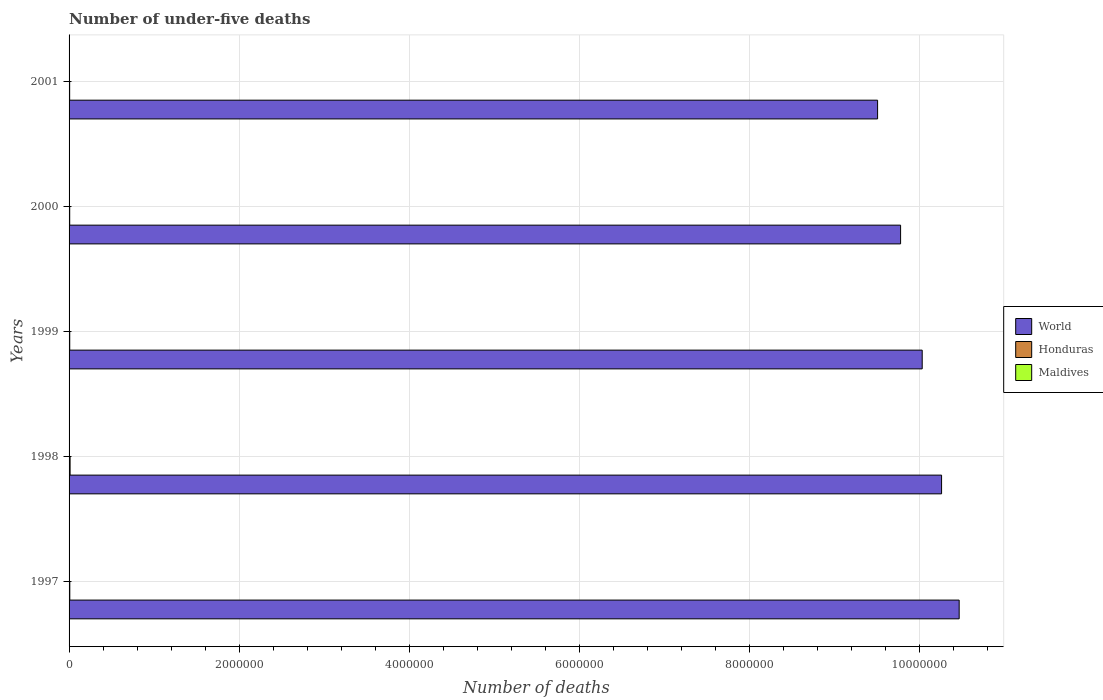Are the number of bars per tick equal to the number of legend labels?
Ensure brevity in your answer.  Yes. How many bars are there on the 5th tick from the bottom?
Offer a terse response. 3. What is the label of the 1st group of bars from the top?
Your answer should be compact. 2001. In how many cases, is the number of bars for a given year not equal to the number of legend labels?
Keep it short and to the point. 0. What is the number of under-five deaths in Honduras in 1999?
Offer a terse response. 7737. Across all years, what is the maximum number of under-five deaths in Honduras?
Offer a terse response. 1.20e+04. Across all years, what is the minimum number of under-five deaths in Honduras?
Your answer should be very brief. 6961. In which year was the number of under-five deaths in Honduras maximum?
Your answer should be compact. 1998. In which year was the number of under-five deaths in Honduras minimum?
Your answer should be very brief. 2001. What is the total number of under-five deaths in World in the graph?
Provide a succinct answer. 5.01e+07. What is the difference between the number of under-five deaths in World in 1997 and that in 2001?
Offer a terse response. 9.60e+05. What is the difference between the number of under-five deaths in Honduras in 1997 and the number of under-five deaths in Maldives in 1999?
Your answer should be very brief. 8169. What is the average number of under-five deaths in Honduras per year?
Your answer should be very brief. 8505.4. In the year 1997, what is the difference between the number of under-five deaths in Maldives and number of under-five deaths in World?
Make the answer very short. -1.05e+07. In how many years, is the number of under-five deaths in World greater than 6800000 ?
Offer a terse response. 5. What is the ratio of the number of under-five deaths in World in 1999 to that in 2000?
Your response must be concise. 1.03. Is the number of under-five deaths in Maldives in 1998 less than that in 1999?
Your response must be concise. No. Is the difference between the number of under-five deaths in Maldives in 1997 and 2000 greater than the difference between the number of under-five deaths in World in 1997 and 2000?
Your answer should be compact. No. What is the difference between the highest and the second highest number of under-five deaths in Honduras?
Your response must be concise. 3490. What is the difference between the highest and the lowest number of under-five deaths in World?
Provide a succinct answer. 9.60e+05. Is the sum of the number of under-five deaths in Maldives in 1997 and 1999 greater than the maximum number of under-five deaths in World across all years?
Give a very brief answer. No. What does the 2nd bar from the top in 1999 represents?
Your answer should be very brief. Honduras. What does the 3rd bar from the bottom in 1998 represents?
Ensure brevity in your answer.  Maldives. Is it the case that in every year, the sum of the number of under-five deaths in Honduras and number of under-five deaths in World is greater than the number of under-five deaths in Maldives?
Your response must be concise. Yes. How are the legend labels stacked?
Offer a very short reply. Vertical. What is the title of the graph?
Offer a terse response. Number of under-five deaths. Does "Congo (Republic)" appear as one of the legend labels in the graph?
Keep it short and to the point. No. What is the label or title of the X-axis?
Your answer should be compact. Number of deaths. What is the label or title of the Y-axis?
Ensure brevity in your answer.  Years. What is the Number of deaths of World in 1997?
Ensure brevity in your answer.  1.05e+07. What is the Number of deaths of Honduras in 1997?
Your answer should be very brief. 8496. What is the Number of deaths of Maldives in 1997?
Your answer should be compact. 436. What is the Number of deaths of World in 1998?
Offer a very short reply. 1.03e+07. What is the Number of deaths in Honduras in 1998?
Keep it short and to the point. 1.20e+04. What is the Number of deaths of Maldives in 1998?
Provide a succinct answer. 379. What is the Number of deaths in World in 1999?
Ensure brevity in your answer.  1.00e+07. What is the Number of deaths in Honduras in 1999?
Provide a short and direct response. 7737. What is the Number of deaths in Maldives in 1999?
Your response must be concise. 327. What is the Number of deaths in World in 2000?
Your answer should be compact. 9.78e+06. What is the Number of deaths in Honduras in 2000?
Provide a succinct answer. 7347. What is the Number of deaths of Maldives in 2000?
Make the answer very short. 281. What is the Number of deaths of World in 2001?
Your answer should be very brief. 9.51e+06. What is the Number of deaths in Honduras in 2001?
Provide a short and direct response. 6961. What is the Number of deaths of Maldives in 2001?
Offer a very short reply. 242. Across all years, what is the maximum Number of deaths in World?
Offer a terse response. 1.05e+07. Across all years, what is the maximum Number of deaths in Honduras?
Keep it short and to the point. 1.20e+04. Across all years, what is the maximum Number of deaths of Maldives?
Ensure brevity in your answer.  436. Across all years, what is the minimum Number of deaths in World?
Make the answer very short. 9.51e+06. Across all years, what is the minimum Number of deaths of Honduras?
Ensure brevity in your answer.  6961. Across all years, what is the minimum Number of deaths of Maldives?
Ensure brevity in your answer.  242. What is the total Number of deaths in World in the graph?
Keep it short and to the point. 5.01e+07. What is the total Number of deaths of Honduras in the graph?
Your response must be concise. 4.25e+04. What is the total Number of deaths of Maldives in the graph?
Keep it short and to the point. 1665. What is the difference between the Number of deaths of World in 1997 and that in 1998?
Your answer should be compact. 2.07e+05. What is the difference between the Number of deaths of Honduras in 1997 and that in 1998?
Your response must be concise. -3490. What is the difference between the Number of deaths in Maldives in 1997 and that in 1998?
Offer a terse response. 57. What is the difference between the Number of deaths in World in 1997 and that in 1999?
Offer a terse response. 4.35e+05. What is the difference between the Number of deaths of Honduras in 1997 and that in 1999?
Keep it short and to the point. 759. What is the difference between the Number of deaths in Maldives in 1997 and that in 1999?
Offer a terse response. 109. What is the difference between the Number of deaths in World in 1997 and that in 2000?
Offer a very short reply. 6.89e+05. What is the difference between the Number of deaths of Honduras in 1997 and that in 2000?
Your answer should be compact. 1149. What is the difference between the Number of deaths in Maldives in 1997 and that in 2000?
Your response must be concise. 155. What is the difference between the Number of deaths of World in 1997 and that in 2001?
Provide a short and direct response. 9.60e+05. What is the difference between the Number of deaths of Honduras in 1997 and that in 2001?
Provide a short and direct response. 1535. What is the difference between the Number of deaths in Maldives in 1997 and that in 2001?
Your response must be concise. 194. What is the difference between the Number of deaths in World in 1998 and that in 1999?
Keep it short and to the point. 2.28e+05. What is the difference between the Number of deaths in Honduras in 1998 and that in 1999?
Offer a very short reply. 4249. What is the difference between the Number of deaths in World in 1998 and that in 2000?
Keep it short and to the point. 4.82e+05. What is the difference between the Number of deaths in Honduras in 1998 and that in 2000?
Keep it short and to the point. 4639. What is the difference between the Number of deaths of Maldives in 1998 and that in 2000?
Offer a terse response. 98. What is the difference between the Number of deaths of World in 1998 and that in 2001?
Your answer should be compact. 7.53e+05. What is the difference between the Number of deaths of Honduras in 1998 and that in 2001?
Offer a very short reply. 5025. What is the difference between the Number of deaths of Maldives in 1998 and that in 2001?
Offer a terse response. 137. What is the difference between the Number of deaths of World in 1999 and that in 2000?
Provide a succinct answer. 2.54e+05. What is the difference between the Number of deaths of Honduras in 1999 and that in 2000?
Your response must be concise. 390. What is the difference between the Number of deaths in Maldives in 1999 and that in 2000?
Offer a terse response. 46. What is the difference between the Number of deaths of World in 1999 and that in 2001?
Provide a succinct answer. 5.25e+05. What is the difference between the Number of deaths in Honduras in 1999 and that in 2001?
Your answer should be very brief. 776. What is the difference between the Number of deaths in World in 2000 and that in 2001?
Your response must be concise. 2.71e+05. What is the difference between the Number of deaths in Honduras in 2000 and that in 2001?
Your response must be concise. 386. What is the difference between the Number of deaths of Maldives in 2000 and that in 2001?
Give a very brief answer. 39. What is the difference between the Number of deaths of World in 1997 and the Number of deaths of Honduras in 1998?
Give a very brief answer. 1.05e+07. What is the difference between the Number of deaths of World in 1997 and the Number of deaths of Maldives in 1998?
Offer a terse response. 1.05e+07. What is the difference between the Number of deaths of Honduras in 1997 and the Number of deaths of Maldives in 1998?
Ensure brevity in your answer.  8117. What is the difference between the Number of deaths of World in 1997 and the Number of deaths of Honduras in 1999?
Offer a terse response. 1.05e+07. What is the difference between the Number of deaths of World in 1997 and the Number of deaths of Maldives in 1999?
Your answer should be compact. 1.05e+07. What is the difference between the Number of deaths of Honduras in 1997 and the Number of deaths of Maldives in 1999?
Your response must be concise. 8169. What is the difference between the Number of deaths of World in 1997 and the Number of deaths of Honduras in 2000?
Make the answer very short. 1.05e+07. What is the difference between the Number of deaths in World in 1997 and the Number of deaths in Maldives in 2000?
Your answer should be compact. 1.05e+07. What is the difference between the Number of deaths of Honduras in 1997 and the Number of deaths of Maldives in 2000?
Your answer should be compact. 8215. What is the difference between the Number of deaths of World in 1997 and the Number of deaths of Honduras in 2001?
Offer a very short reply. 1.05e+07. What is the difference between the Number of deaths of World in 1997 and the Number of deaths of Maldives in 2001?
Give a very brief answer. 1.05e+07. What is the difference between the Number of deaths in Honduras in 1997 and the Number of deaths in Maldives in 2001?
Provide a short and direct response. 8254. What is the difference between the Number of deaths of World in 1998 and the Number of deaths of Honduras in 1999?
Your answer should be very brief. 1.03e+07. What is the difference between the Number of deaths in World in 1998 and the Number of deaths in Maldives in 1999?
Your response must be concise. 1.03e+07. What is the difference between the Number of deaths in Honduras in 1998 and the Number of deaths in Maldives in 1999?
Offer a terse response. 1.17e+04. What is the difference between the Number of deaths of World in 1998 and the Number of deaths of Honduras in 2000?
Your answer should be compact. 1.03e+07. What is the difference between the Number of deaths in World in 1998 and the Number of deaths in Maldives in 2000?
Give a very brief answer. 1.03e+07. What is the difference between the Number of deaths of Honduras in 1998 and the Number of deaths of Maldives in 2000?
Offer a terse response. 1.17e+04. What is the difference between the Number of deaths of World in 1998 and the Number of deaths of Honduras in 2001?
Give a very brief answer. 1.03e+07. What is the difference between the Number of deaths in World in 1998 and the Number of deaths in Maldives in 2001?
Keep it short and to the point. 1.03e+07. What is the difference between the Number of deaths of Honduras in 1998 and the Number of deaths of Maldives in 2001?
Your answer should be very brief. 1.17e+04. What is the difference between the Number of deaths of World in 1999 and the Number of deaths of Honduras in 2000?
Give a very brief answer. 1.00e+07. What is the difference between the Number of deaths in World in 1999 and the Number of deaths in Maldives in 2000?
Give a very brief answer. 1.00e+07. What is the difference between the Number of deaths of Honduras in 1999 and the Number of deaths of Maldives in 2000?
Your response must be concise. 7456. What is the difference between the Number of deaths of World in 1999 and the Number of deaths of Honduras in 2001?
Provide a short and direct response. 1.00e+07. What is the difference between the Number of deaths in World in 1999 and the Number of deaths in Maldives in 2001?
Your answer should be very brief. 1.00e+07. What is the difference between the Number of deaths in Honduras in 1999 and the Number of deaths in Maldives in 2001?
Provide a short and direct response. 7495. What is the difference between the Number of deaths of World in 2000 and the Number of deaths of Honduras in 2001?
Your answer should be compact. 9.78e+06. What is the difference between the Number of deaths of World in 2000 and the Number of deaths of Maldives in 2001?
Offer a terse response. 9.78e+06. What is the difference between the Number of deaths of Honduras in 2000 and the Number of deaths of Maldives in 2001?
Keep it short and to the point. 7105. What is the average Number of deaths in World per year?
Provide a succinct answer. 1.00e+07. What is the average Number of deaths in Honduras per year?
Make the answer very short. 8505.4. What is the average Number of deaths of Maldives per year?
Make the answer very short. 333. In the year 1997, what is the difference between the Number of deaths in World and Number of deaths in Honduras?
Your answer should be compact. 1.05e+07. In the year 1997, what is the difference between the Number of deaths of World and Number of deaths of Maldives?
Offer a very short reply. 1.05e+07. In the year 1997, what is the difference between the Number of deaths in Honduras and Number of deaths in Maldives?
Give a very brief answer. 8060. In the year 1998, what is the difference between the Number of deaths of World and Number of deaths of Honduras?
Give a very brief answer. 1.03e+07. In the year 1998, what is the difference between the Number of deaths in World and Number of deaths in Maldives?
Provide a succinct answer. 1.03e+07. In the year 1998, what is the difference between the Number of deaths in Honduras and Number of deaths in Maldives?
Your answer should be compact. 1.16e+04. In the year 1999, what is the difference between the Number of deaths in World and Number of deaths in Honduras?
Your answer should be compact. 1.00e+07. In the year 1999, what is the difference between the Number of deaths in World and Number of deaths in Maldives?
Provide a short and direct response. 1.00e+07. In the year 1999, what is the difference between the Number of deaths in Honduras and Number of deaths in Maldives?
Provide a short and direct response. 7410. In the year 2000, what is the difference between the Number of deaths of World and Number of deaths of Honduras?
Ensure brevity in your answer.  9.78e+06. In the year 2000, what is the difference between the Number of deaths in World and Number of deaths in Maldives?
Provide a short and direct response. 9.78e+06. In the year 2000, what is the difference between the Number of deaths of Honduras and Number of deaths of Maldives?
Your answer should be compact. 7066. In the year 2001, what is the difference between the Number of deaths of World and Number of deaths of Honduras?
Ensure brevity in your answer.  9.51e+06. In the year 2001, what is the difference between the Number of deaths of World and Number of deaths of Maldives?
Your response must be concise. 9.51e+06. In the year 2001, what is the difference between the Number of deaths of Honduras and Number of deaths of Maldives?
Provide a short and direct response. 6719. What is the ratio of the Number of deaths of World in 1997 to that in 1998?
Your answer should be very brief. 1.02. What is the ratio of the Number of deaths of Honduras in 1997 to that in 1998?
Provide a succinct answer. 0.71. What is the ratio of the Number of deaths of Maldives in 1997 to that in 1998?
Your answer should be very brief. 1.15. What is the ratio of the Number of deaths in World in 1997 to that in 1999?
Give a very brief answer. 1.04. What is the ratio of the Number of deaths in Honduras in 1997 to that in 1999?
Provide a succinct answer. 1.1. What is the ratio of the Number of deaths of World in 1997 to that in 2000?
Your answer should be very brief. 1.07. What is the ratio of the Number of deaths of Honduras in 1997 to that in 2000?
Your response must be concise. 1.16. What is the ratio of the Number of deaths of Maldives in 1997 to that in 2000?
Your answer should be compact. 1.55. What is the ratio of the Number of deaths in World in 1997 to that in 2001?
Your response must be concise. 1.1. What is the ratio of the Number of deaths of Honduras in 1997 to that in 2001?
Keep it short and to the point. 1.22. What is the ratio of the Number of deaths of Maldives in 1997 to that in 2001?
Your answer should be compact. 1.8. What is the ratio of the Number of deaths in World in 1998 to that in 1999?
Provide a succinct answer. 1.02. What is the ratio of the Number of deaths of Honduras in 1998 to that in 1999?
Your response must be concise. 1.55. What is the ratio of the Number of deaths in Maldives in 1998 to that in 1999?
Keep it short and to the point. 1.16. What is the ratio of the Number of deaths of World in 1998 to that in 2000?
Offer a terse response. 1.05. What is the ratio of the Number of deaths of Honduras in 1998 to that in 2000?
Your answer should be very brief. 1.63. What is the ratio of the Number of deaths in Maldives in 1998 to that in 2000?
Your response must be concise. 1.35. What is the ratio of the Number of deaths in World in 1998 to that in 2001?
Your answer should be very brief. 1.08. What is the ratio of the Number of deaths of Honduras in 1998 to that in 2001?
Your answer should be compact. 1.72. What is the ratio of the Number of deaths in Maldives in 1998 to that in 2001?
Give a very brief answer. 1.57. What is the ratio of the Number of deaths of World in 1999 to that in 2000?
Provide a succinct answer. 1.03. What is the ratio of the Number of deaths of Honduras in 1999 to that in 2000?
Your answer should be very brief. 1.05. What is the ratio of the Number of deaths of Maldives in 1999 to that in 2000?
Make the answer very short. 1.16. What is the ratio of the Number of deaths in World in 1999 to that in 2001?
Your answer should be compact. 1.06. What is the ratio of the Number of deaths in Honduras in 1999 to that in 2001?
Your answer should be compact. 1.11. What is the ratio of the Number of deaths of Maldives in 1999 to that in 2001?
Offer a very short reply. 1.35. What is the ratio of the Number of deaths of World in 2000 to that in 2001?
Your answer should be very brief. 1.03. What is the ratio of the Number of deaths in Honduras in 2000 to that in 2001?
Make the answer very short. 1.06. What is the ratio of the Number of deaths in Maldives in 2000 to that in 2001?
Keep it short and to the point. 1.16. What is the difference between the highest and the second highest Number of deaths in World?
Ensure brevity in your answer.  2.07e+05. What is the difference between the highest and the second highest Number of deaths in Honduras?
Provide a short and direct response. 3490. What is the difference between the highest and the lowest Number of deaths of World?
Provide a short and direct response. 9.60e+05. What is the difference between the highest and the lowest Number of deaths of Honduras?
Your answer should be compact. 5025. What is the difference between the highest and the lowest Number of deaths in Maldives?
Your response must be concise. 194. 